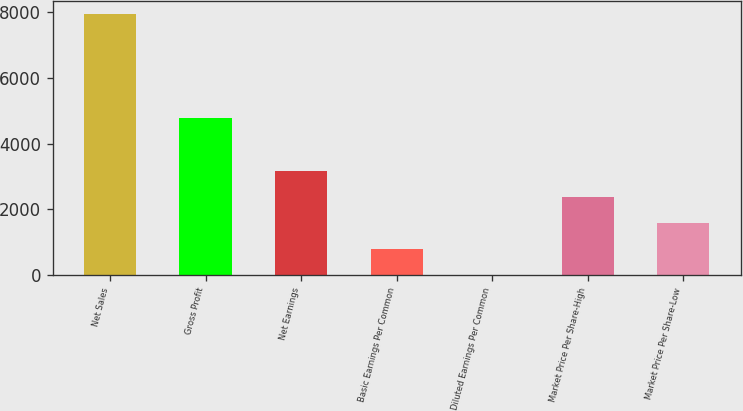<chart> <loc_0><loc_0><loc_500><loc_500><bar_chart><fcel>Net Sales<fcel>Gross Profit<fcel>Net Earnings<fcel>Basic Earnings Per Common<fcel>Diluted Earnings Per Common<fcel>Market Price Per Share-High<fcel>Market Price Per Share-Low<nl><fcel>7950.3<fcel>4771.9<fcel>3180.7<fcel>795.91<fcel>0.98<fcel>2385.77<fcel>1590.84<nl></chart> 